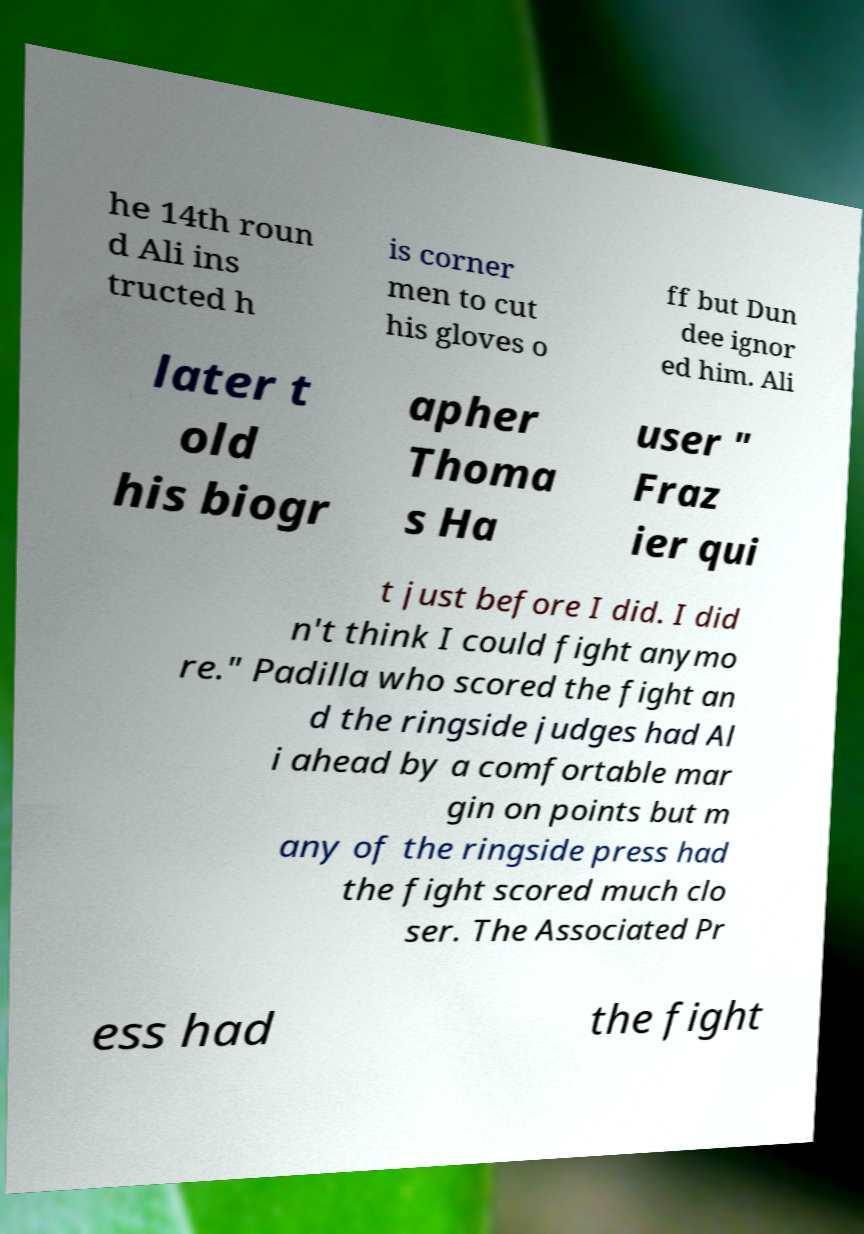Could you assist in decoding the text presented in this image and type it out clearly? he 14th roun d Ali ins tructed h is corner men to cut his gloves o ff but Dun dee ignor ed him. Ali later t old his biogr apher Thoma s Ha user " Fraz ier qui t just before I did. I did n't think I could fight anymo re." Padilla who scored the fight an d the ringside judges had Al i ahead by a comfortable mar gin on points but m any of the ringside press had the fight scored much clo ser. The Associated Pr ess had the fight 